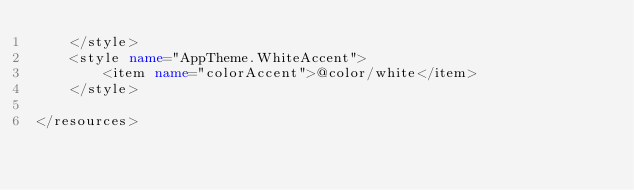<code> <loc_0><loc_0><loc_500><loc_500><_XML_>    </style>
    <style name="AppTheme.WhiteAccent">
        <item name="colorAccent">@color/white</item>
    </style>

</resources>
</code> 